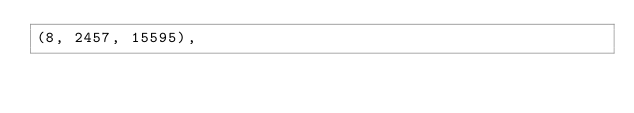<code> <loc_0><loc_0><loc_500><loc_500><_SQL_>(8, 2457, 15595),</code> 